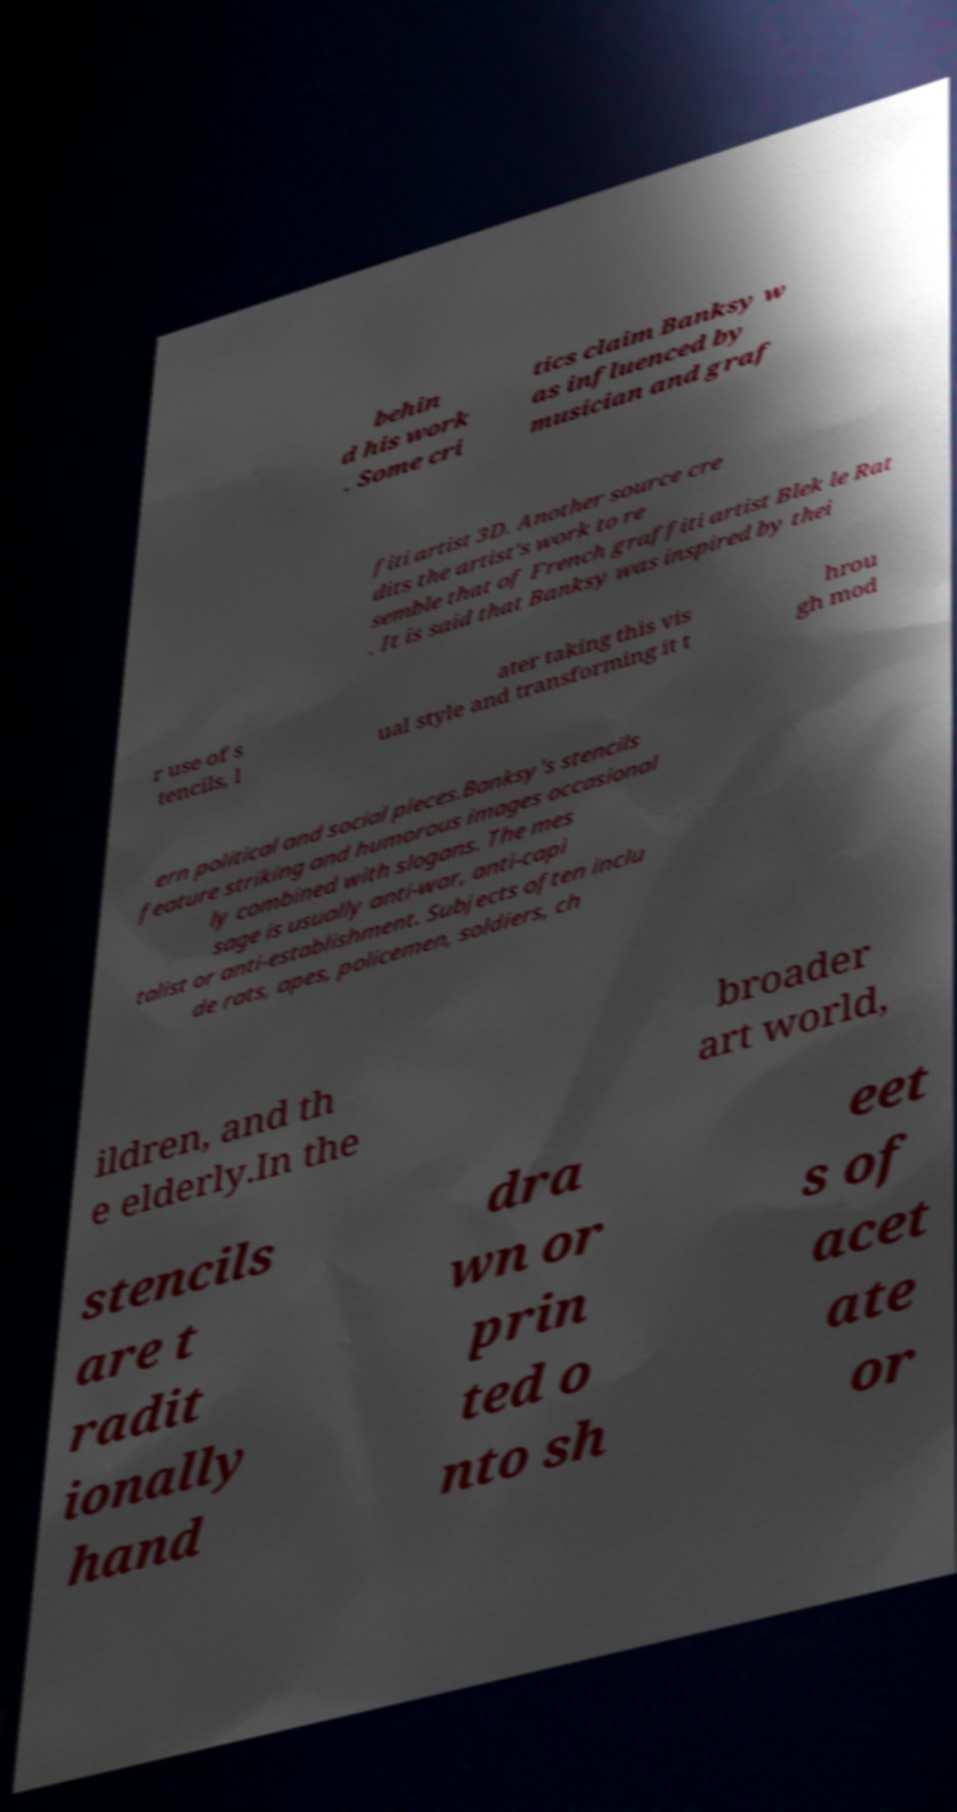Can you read and provide the text displayed in the image?This photo seems to have some interesting text. Can you extract and type it out for me? behin d his work . Some cri tics claim Banksy w as influenced by musician and graf fiti artist 3D. Another source cre dits the artist's work to re semble that of French graffiti artist Blek le Rat . It is said that Banksy was inspired by thei r use of s tencils, l ater taking this vis ual style and transforming it t hrou gh mod ern political and social pieces.Banksy's stencils feature striking and humorous images occasional ly combined with slogans. The mes sage is usually anti-war, anti-capi talist or anti-establishment. Subjects often inclu de rats, apes, policemen, soldiers, ch ildren, and th e elderly.In the broader art world, stencils are t radit ionally hand dra wn or prin ted o nto sh eet s of acet ate or 